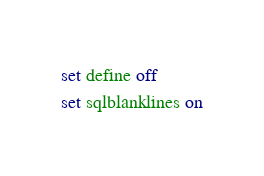<code> <loc_0><loc_0><loc_500><loc_500><_SQL_>set define off
set sqlblanklines on</code> 